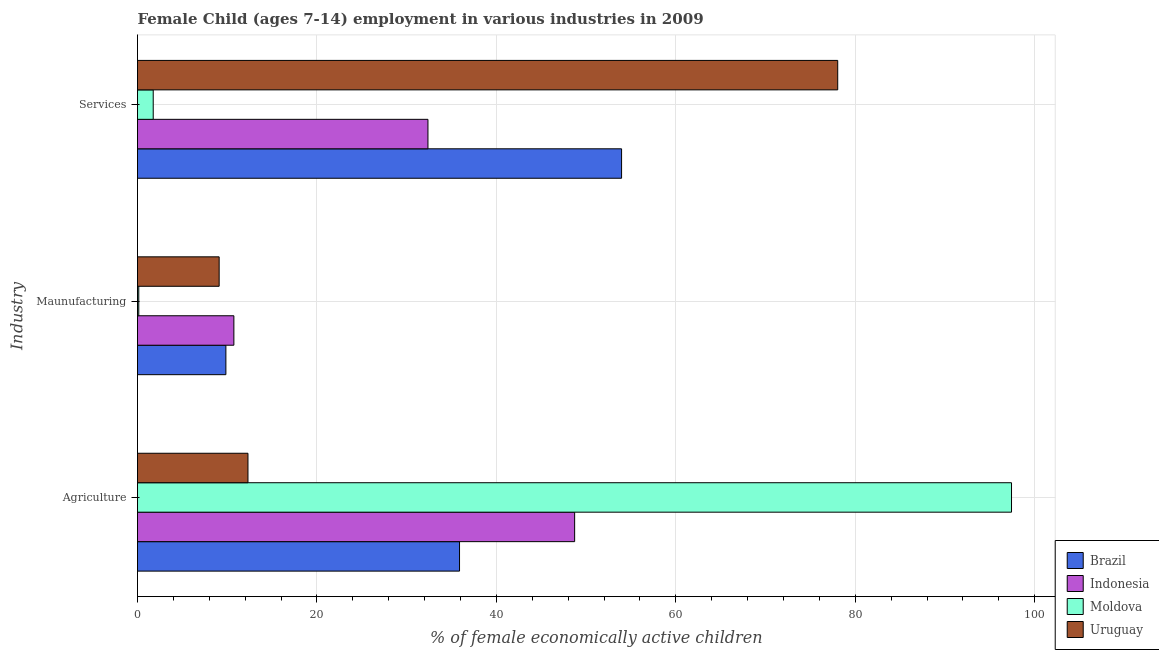How many different coloured bars are there?
Your answer should be very brief. 4. How many groups of bars are there?
Keep it short and to the point. 3. Are the number of bars on each tick of the Y-axis equal?
Keep it short and to the point. Yes. What is the label of the 3rd group of bars from the top?
Provide a short and direct response. Agriculture. What is the percentage of economically active children in services in Indonesia?
Offer a very short reply. 32.37. Across all countries, what is the maximum percentage of economically active children in services?
Offer a terse response. 78.04. Across all countries, what is the minimum percentage of economically active children in agriculture?
Keep it short and to the point. 12.31. In which country was the percentage of economically active children in services minimum?
Offer a very short reply. Moldova. What is the total percentage of economically active children in services in the graph?
Your answer should be compact. 166.11. What is the difference between the percentage of economically active children in services in Brazil and that in Moldova?
Your response must be concise. 52.2. What is the difference between the percentage of economically active children in services in Brazil and the percentage of economically active children in agriculture in Uruguay?
Keep it short and to the point. 41.64. What is the average percentage of economically active children in manufacturing per country?
Keep it short and to the point. 7.46. What is the difference between the percentage of economically active children in manufacturing and percentage of economically active children in agriculture in Brazil?
Make the answer very short. -26.04. In how many countries, is the percentage of economically active children in manufacturing greater than 84 %?
Provide a succinct answer. 0. What is the ratio of the percentage of economically active children in agriculture in Brazil to that in Uruguay?
Keep it short and to the point. 2.92. Is the difference between the percentage of economically active children in manufacturing in Moldova and Brazil greater than the difference between the percentage of economically active children in agriculture in Moldova and Brazil?
Ensure brevity in your answer.  No. What is the difference between the highest and the second highest percentage of economically active children in agriculture?
Provide a succinct answer. 48.69. What is the difference between the highest and the lowest percentage of economically active children in services?
Offer a very short reply. 76.29. In how many countries, is the percentage of economically active children in services greater than the average percentage of economically active children in services taken over all countries?
Provide a succinct answer. 2. What does the 3rd bar from the top in Services represents?
Ensure brevity in your answer.  Indonesia. How many bars are there?
Make the answer very short. 12. How many countries are there in the graph?
Offer a terse response. 4. Where does the legend appear in the graph?
Give a very brief answer. Bottom right. What is the title of the graph?
Your answer should be compact. Female Child (ages 7-14) employment in various industries in 2009. What is the label or title of the X-axis?
Offer a terse response. % of female economically active children. What is the label or title of the Y-axis?
Ensure brevity in your answer.  Industry. What is the % of female economically active children in Brazil in Agriculture?
Keep it short and to the point. 35.89. What is the % of female economically active children in Indonesia in Agriculture?
Offer a terse response. 48.72. What is the % of female economically active children of Moldova in Agriculture?
Your response must be concise. 97.41. What is the % of female economically active children of Uruguay in Agriculture?
Your answer should be compact. 12.31. What is the % of female economically active children in Brazil in Maunufacturing?
Offer a terse response. 9.85. What is the % of female economically active children in Indonesia in Maunufacturing?
Give a very brief answer. 10.74. What is the % of female economically active children of Moldova in Maunufacturing?
Provide a succinct answer. 0.14. What is the % of female economically active children of Uruguay in Maunufacturing?
Ensure brevity in your answer.  9.1. What is the % of female economically active children of Brazil in Services?
Your response must be concise. 53.95. What is the % of female economically active children of Indonesia in Services?
Provide a short and direct response. 32.37. What is the % of female economically active children in Moldova in Services?
Give a very brief answer. 1.75. What is the % of female economically active children of Uruguay in Services?
Your answer should be very brief. 78.04. Across all Industry, what is the maximum % of female economically active children of Brazil?
Your answer should be very brief. 53.95. Across all Industry, what is the maximum % of female economically active children of Indonesia?
Make the answer very short. 48.72. Across all Industry, what is the maximum % of female economically active children in Moldova?
Offer a terse response. 97.41. Across all Industry, what is the maximum % of female economically active children in Uruguay?
Offer a very short reply. 78.04. Across all Industry, what is the minimum % of female economically active children of Brazil?
Provide a short and direct response. 9.85. Across all Industry, what is the minimum % of female economically active children in Indonesia?
Provide a succinct answer. 10.74. Across all Industry, what is the minimum % of female economically active children in Moldova?
Your answer should be compact. 0.14. Across all Industry, what is the minimum % of female economically active children of Uruguay?
Keep it short and to the point. 9.1. What is the total % of female economically active children in Brazil in the graph?
Your answer should be very brief. 99.69. What is the total % of female economically active children of Indonesia in the graph?
Keep it short and to the point. 91.83. What is the total % of female economically active children in Moldova in the graph?
Provide a succinct answer. 99.3. What is the total % of female economically active children in Uruguay in the graph?
Keep it short and to the point. 99.45. What is the difference between the % of female economically active children of Brazil in Agriculture and that in Maunufacturing?
Provide a succinct answer. 26.04. What is the difference between the % of female economically active children of Indonesia in Agriculture and that in Maunufacturing?
Give a very brief answer. 37.98. What is the difference between the % of female economically active children of Moldova in Agriculture and that in Maunufacturing?
Make the answer very short. 97.27. What is the difference between the % of female economically active children in Uruguay in Agriculture and that in Maunufacturing?
Provide a succinct answer. 3.21. What is the difference between the % of female economically active children of Brazil in Agriculture and that in Services?
Offer a terse response. -18.06. What is the difference between the % of female economically active children of Indonesia in Agriculture and that in Services?
Your response must be concise. 16.35. What is the difference between the % of female economically active children of Moldova in Agriculture and that in Services?
Keep it short and to the point. 95.66. What is the difference between the % of female economically active children of Uruguay in Agriculture and that in Services?
Make the answer very short. -65.73. What is the difference between the % of female economically active children in Brazil in Maunufacturing and that in Services?
Make the answer very short. -44.1. What is the difference between the % of female economically active children in Indonesia in Maunufacturing and that in Services?
Ensure brevity in your answer.  -21.63. What is the difference between the % of female economically active children of Moldova in Maunufacturing and that in Services?
Your answer should be very brief. -1.61. What is the difference between the % of female economically active children of Uruguay in Maunufacturing and that in Services?
Your response must be concise. -68.94. What is the difference between the % of female economically active children of Brazil in Agriculture and the % of female economically active children of Indonesia in Maunufacturing?
Provide a short and direct response. 25.15. What is the difference between the % of female economically active children of Brazil in Agriculture and the % of female economically active children of Moldova in Maunufacturing?
Offer a very short reply. 35.75. What is the difference between the % of female economically active children of Brazil in Agriculture and the % of female economically active children of Uruguay in Maunufacturing?
Your answer should be very brief. 26.79. What is the difference between the % of female economically active children of Indonesia in Agriculture and the % of female economically active children of Moldova in Maunufacturing?
Offer a very short reply. 48.58. What is the difference between the % of female economically active children in Indonesia in Agriculture and the % of female economically active children in Uruguay in Maunufacturing?
Offer a very short reply. 39.62. What is the difference between the % of female economically active children in Moldova in Agriculture and the % of female economically active children in Uruguay in Maunufacturing?
Offer a very short reply. 88.31. What is the difference between the % of female economically active children of Brazil in Agriculture and the % of female economically active children of Indonesia in Services?
Provide a short and direct response. 3.52. What is the difference between the % of female economically active children in Brazil in Agriculture and the % of female economically active children in Moldova in Services?
Provide a short and direct response. 34.14. What is the difference between the % of female economically active children of Brazil in Agriculture and the % of female economically active children of Uruguay in Services?
Your answer should be compact. -42.15. What is the difference between the % of female economically active children in Indonesia in Agriculture and the % of female economically active children in Moldova in Services?
Make the answer very short. 46.97. What is the difference between the % of female economically active children in Indonesia in Agriculture and the % of female economically active children in Uruguay in Services?
Your response must be concise. -29.32. What is the difference between the % of female economically active children in Moldova in Agriculture and the % of female economically active children in Uruguay in Services?
Your answer should be compact. 19.37. What is the difference between the % of female economically active children in Brazil in Maunufacturing and the % of female economically active children in Indonesia in Services?
Your answer should be very brief. -22.52. What is the difference between the % of female economically active children in Brazil in Maunufacturing and the % of female economically active children in Uruguay in Services?
Ensure brevity in your answer.  -68.19. What is the difference between the % of female economically active children of Indonesia in Maunufacturing and the % of female economically active children of Moldova in Services?
Ensure brevity in your answer.  8.99. What is the difference between the % of female economically active children in Indonesia in Maunufacturing and the % of female economically active children in Uruguay in Services?
Provide a short and direct response. -67.3. What is the difference between the % of female economically active children of Moldova in Maunufacturing and the % of female economically active children of Uruguay in Services?
Your answer should be compact. -77.9. What is the average % of female economically active children in Brazil per Industry?
Keep it short and to the point. 33.23. What is the average % of female economically active children of Indonesia per Industry?
Keep it short and to the point. 30.61. What is the average % of female economically active children of Moldova per Industry?
Give a very brief answer. 33.1. What is the average % of female economically active children of Uruguay per Industry?
Offer a terse response. 33.15. What is the difference between the % of female economically active children in Brazil and % of female economically active children in Indonesia in Agriculture?
Your answer should be very brief. -12.83. What is the difference between the % of female economically active children of Brazil and % of female economically active children of Moldova in Agriculture?
Provide a short and direct response. -61.52. What is the difference between the % of female economically active children in Brazil and % of female economically active children in Uruguay in Agriculture?
Your answer should be compact. 23.58. What is the difference between the % of female economically active children of Indonesia and % of female economically active children of Moldova in Agriculture?
Give a very brief answer. -48.69. What is the difference between the % of female economically active children in Indonesia and % of female economically active children in Uruguay in Agriculture?
Make the answer very short. 36.41. What is the difference between the % of female economically active children of Moldova and % of female economically active children of Uruguay in Agriculture?
Keep it short and to the point. 85.1. What is the difference between the % of female economically active children in Brazil and % of female economically active children in Indonesia in Maunufacturing?
Provide a short and direct response. -0.89. What is the difference between the % of female economically active children of Brazil and % of female economically active children of Moldova in Maunufacturing?
Provide a short and direct response. 9.71. What is the difference between the % of female economically active children of Brazil and % of female economically active children of Uruguay in Maunufacturing?
Your response must be concise. 0.75. What is the difference between the % of female economically active children in Indonesia and % of female economically active children in Moldova in Maunufacturing?
Provide a short and direct response. 10.6. What is the difference between the % of female economically active children in Indonesia and % of female economically active children in Uruguay in Maunufacturing?
Keep it short and to the point. 1.64. What is the difference between the % of female economically active children in Moldova and % of female economically active children in Uruguay in Maunufacturing?
Keep it short and to the point. -8.96. What is the difference between the % of female economically active children of Brazil and % of female economically active children of Indonesia in Services?
Your answer should be very brief. 21.58. What is the difference between the % of female economically active children in Brazil and % of female economically active children in Moldova in Services?
Make the answer very short. 52.2. What is the difference between the % of female economically active children of Brazil and % of female economically active children of Uruguay in Services?
Your response must be concise. -24.09. What is the difference between the % of female economically active children in Indonesia and % of female economically active children in Moldova in Services?
Offer a very short reply. 30.62. What is the difference between the % of female economically active children of Indonesia and % of female economically active children of Uruguay in Services?
Offer a terse response. -45.67. What is the difference between the % of female economically active children in Moldova and % of female economically active children in Uruguay in Services?
Your response must be concise. -76.29. What is the ratio of the % of female economically active children of Brazil in Agriculture to that in Maunufacturing?
Offer a terse response. 3.64. What is the ratio of the % of female economically active children of Indonesia in Agriculture to that in Maunufacturing?
Your answer should be compact. 4.54. What is the ratio of the % of female economically active children of Moldova in Agriculture to that in Maunufacturing?
Ensure brevity in your answer.  695.79. What is the ratio of the % of female economically active children in Uruguay in Agriculture to that in Maunufacturing?
Your answer should be compact. 1.35. What is the ratio of the % of female economically active children of Brazil in Agriculture to that in Services?
Offer a very short reply. 0.67. What is the ratio of the % of female economically active children of Indonesia in Agriculture to that in Services?
Keep it short and to the point. 1.51. What is the ratio of the % of female economically active children in Moldova in Agriculture to that in Services?
Give a very brief answer. 55.66. What is the ratio of the % of female economically active children in Uruguay in Agriculture to that in Services?
Offer a very short reply. 0.16. What is the ratio of the % of female economically active children in Brazil in Maunufacturing to that in Services?
Your answer should be very brief. 0.18. What is the ratio of the % of female economically active children of Indonesia in Maunufacturing to that in Services?
Your answer should be very brief. 0.33. What is the ratio of the % of female economically active children in Moldova in Maunufacturing to that in Services?
Your answer should be very brief. 0.08. What is the ratio of the % of female economically active children of Uruguay in Maunufacturing to that in Services?
Provide a short and direct response. 0.12. What is the difference between the highest and the second highest % of female economically active children of Brazil?
Provide a succinct answer. 18.06. What is the difference between the highest and the second highest % of female economically active children of Indonesia?
Provide a short and direct response. 16.35. What is the difference between the highest and the second highest % of female economically active children of Moldova?
Offer a very short reply. 95.66. What is the difference between the highest and the second highest % of female economically active children in Uruguay?
Keep it short and to the point. 65.73. What is the difference between the highest and the lowest % of female economically active children in Brazil?
Offer a very short reply. 44.1. What is the difference between the highest and the lowest % of female economically active children of Indonesia?
Offer a very short reply. 37.98. What is the difference between the highest and the lowest % of female economically active children in Moldova?
Give a very brief answer. 97.27. What is the difference between the highest and the lowest % of female economically active children in Uruguay?
Provide a succinct answer. 68.94. 